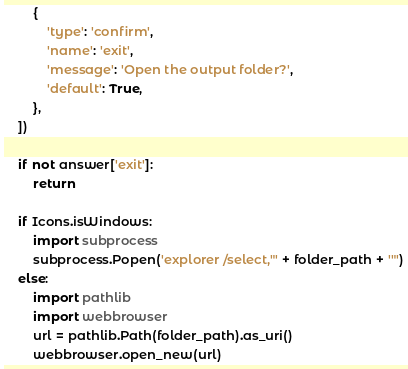Convert code to text. <code><loc_0><loc_0><loc_500><loc_500><_Python_>        {
            'type': 'confirm',
            'name': 'exit',
            'message': 'Open the output folder?',
            'default': True,
        },
    ])

    if not answer['exit']:
        return

    if Icons.isWindows:
        import subprocess
        subprocess.Popen('explorer /select,"' + folder_path + '"')
    else:
        import pathlib
        import webbrowser
        url = pathlib.Path(folder_path).as_uri()
        webbrowser.open_new(url)
</code> 